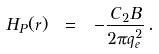Convert formula to latex. <formula><loc_0><loc_0><loc_500><loc_500>H _ { P } ( r ) \ = \ - \frac { C _ { 2 } B } { 2 \pi q _ { e } ^ { 2 } } \, .</formula> 